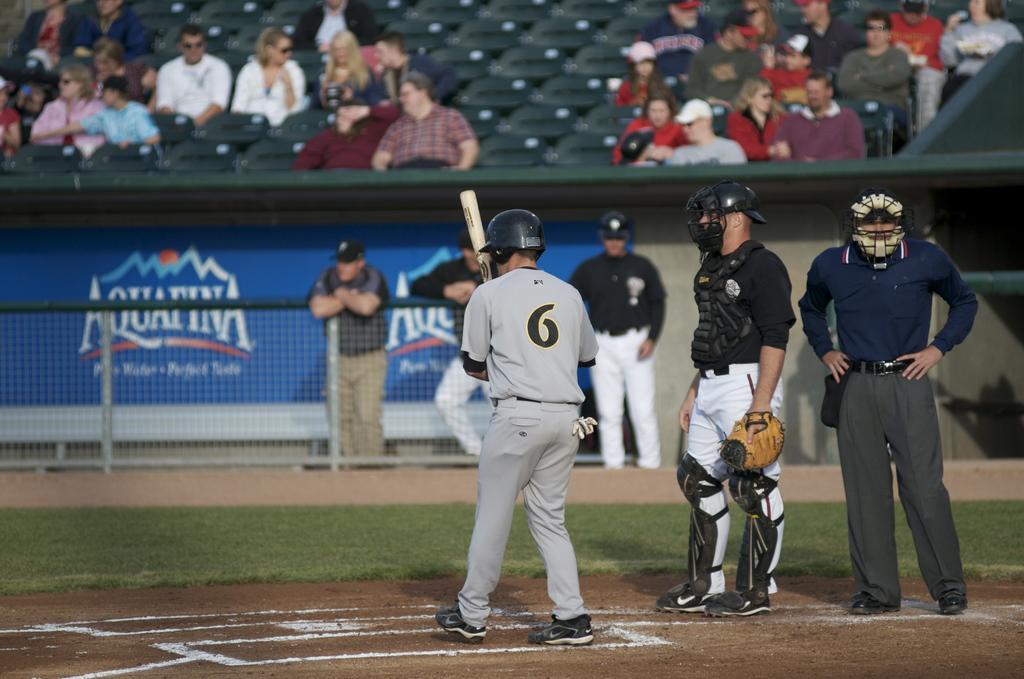Describe this image in one or two sentences. In this picture we can see three people standing on the ground, they are wearing helmets, one person is holding a bat, another person is wearing a glove and in the background we can see a fence, advertisement board, wall and a group of people, some people are sitting on seats, some people are standing. 